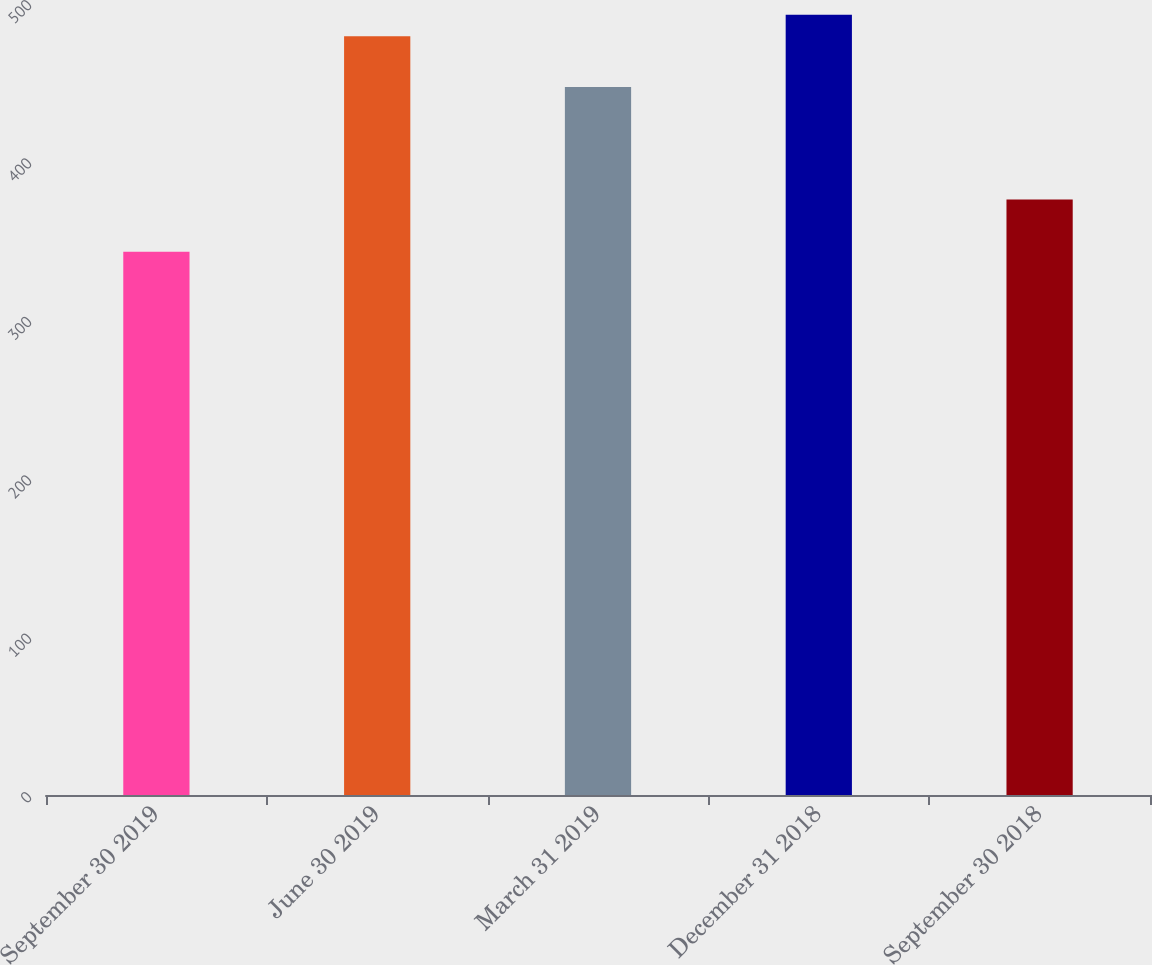<chart> <loc_0><loc_0><loc_500><loc_500><bar_chart><fcel>September 30 2019<fcel>June 30 2019<fcel>March 31 2019<fcel>December 31 2018<fcel>September 30 2018<nl><fcel>343<fcel>479<fcel>447<fcel>492.6<fcel>376<nl></chart> 